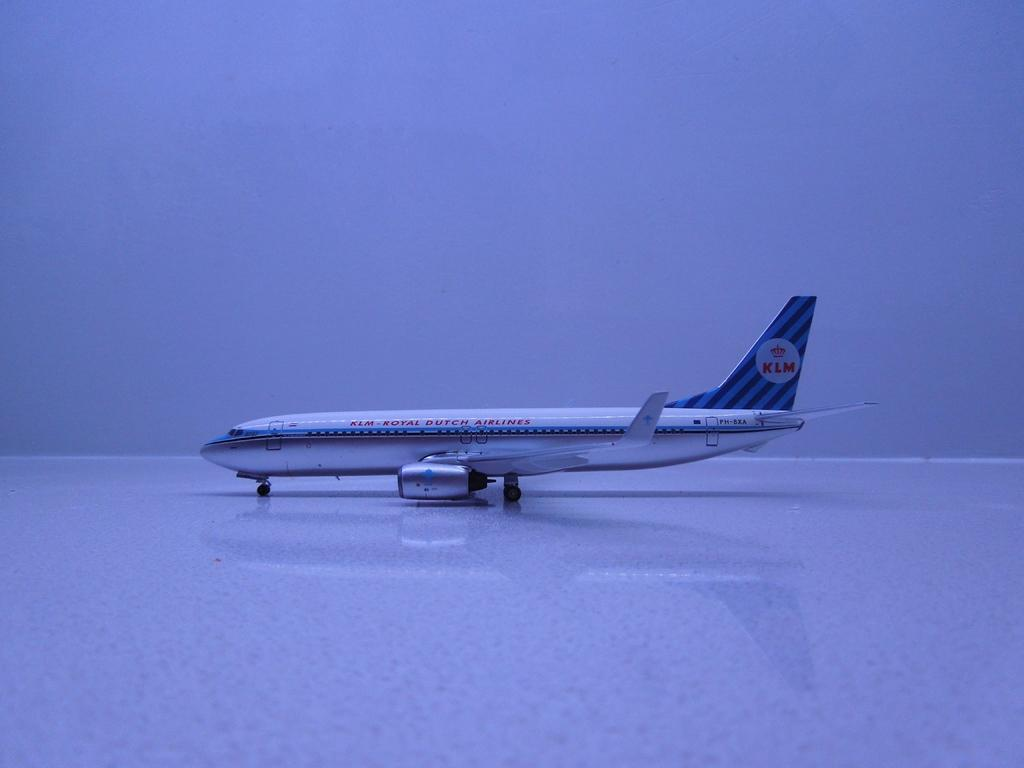What is the main subject of the image? The main subject of the image is an airplane. Are there any words or letters on the airplane? Yes, there is text written on the airplane. What type of cactus can be seen growing near the airplane in the image? There is no cactus present in the image; it only features an airplane with text written on it. What is the title of the book that the airplane is reading in the image? The image does not depict an airplane reading a book, so there is no title to reference. 